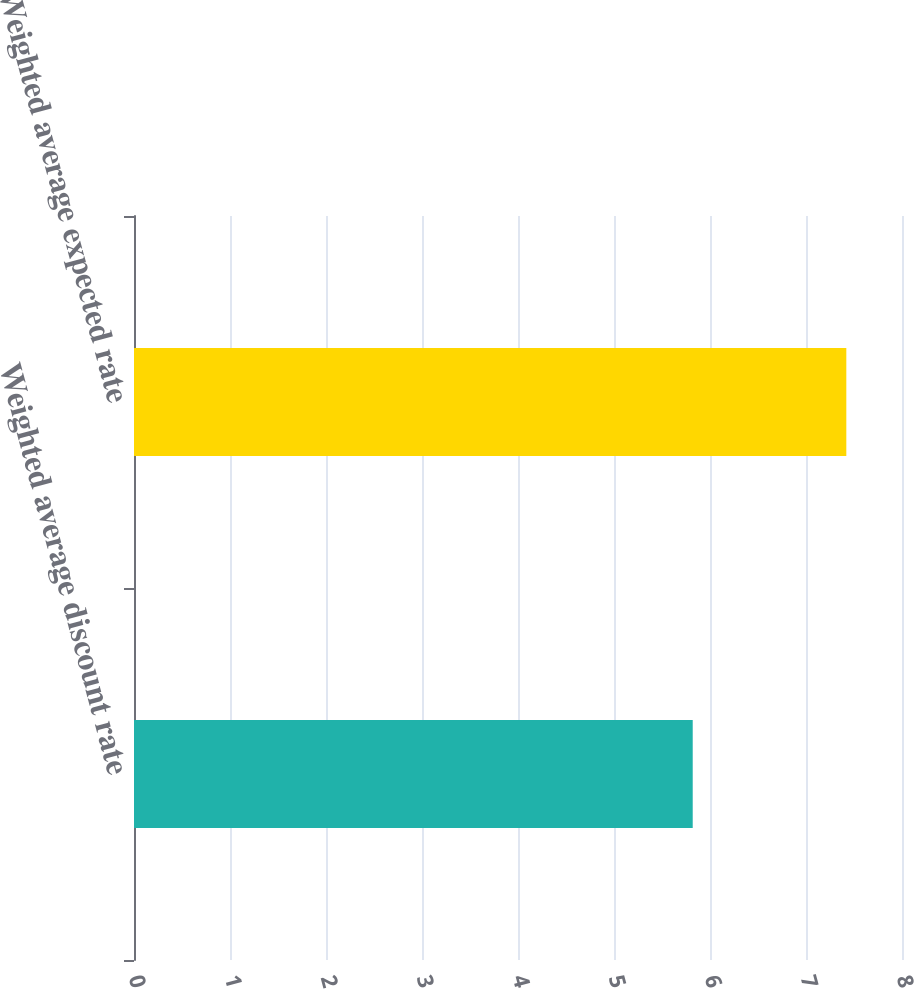<chart> <loc_0><loc_0><loc_500><loc_500><bar_chart><fcel>Weighted average discount rate<fcel>Weighted average expected rate<nl><fcel>5.82<fcel>7.42<nl></chart> 